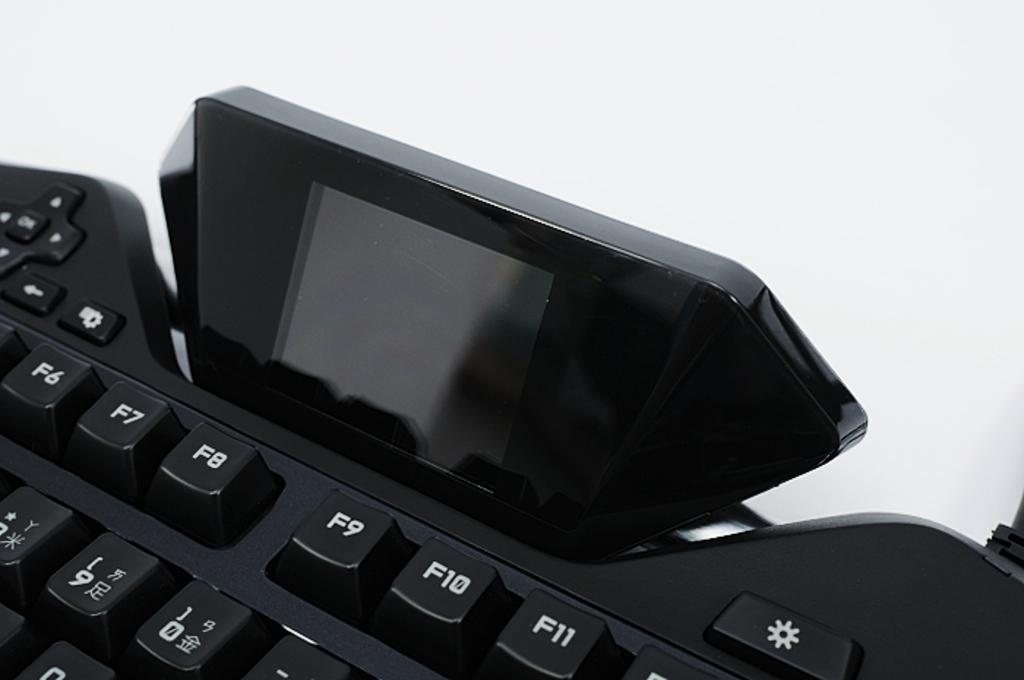<image>
Describe the image concisely. Black keyboard with the F10 button between the F9 and F11 buttons. 